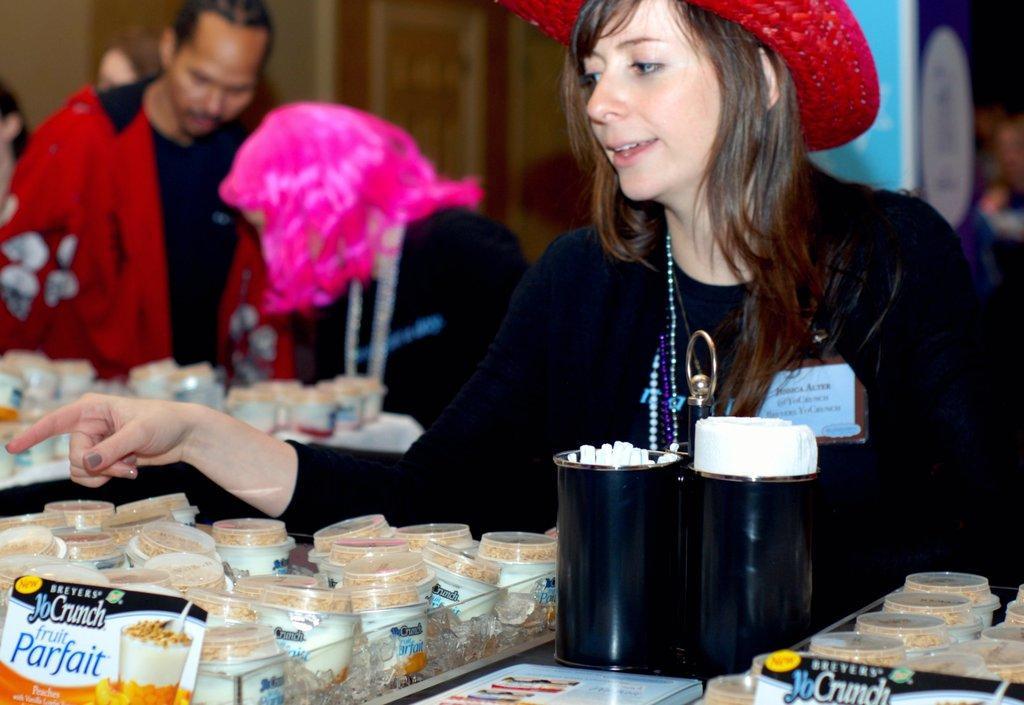Can you describe this image briefly? Here we can see three persons. There are boxes, food packet, tissue papers, and cups. There is a blur background. 